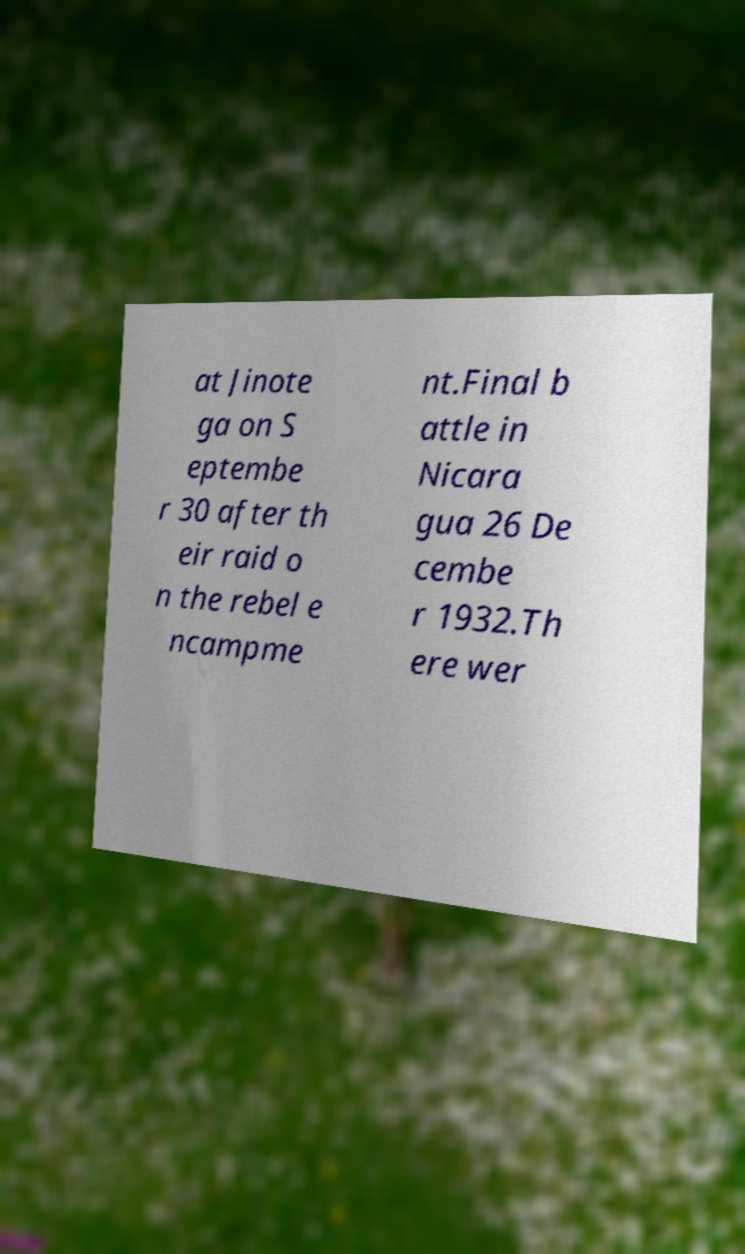There's text embedded in this image that I need extracted. Can you transcribe it verbatim? at Jinote ga on S eptembe r 30 after th eir raid o n the rebel e ncampme nt.Final b attle in Nicara gua 26 De cembe r 1932.Th ere wer 